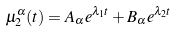<formula> <loc_0><loc_0><loc_500><loc_500>\mu ^ { \alpha } _ { 2 } ( t ) = A _ { \alpha } e ^ { \lambda _ { 1 } t } + B _ { \alpha } e ^ { \lambda _ { 2 } t }</formula> 